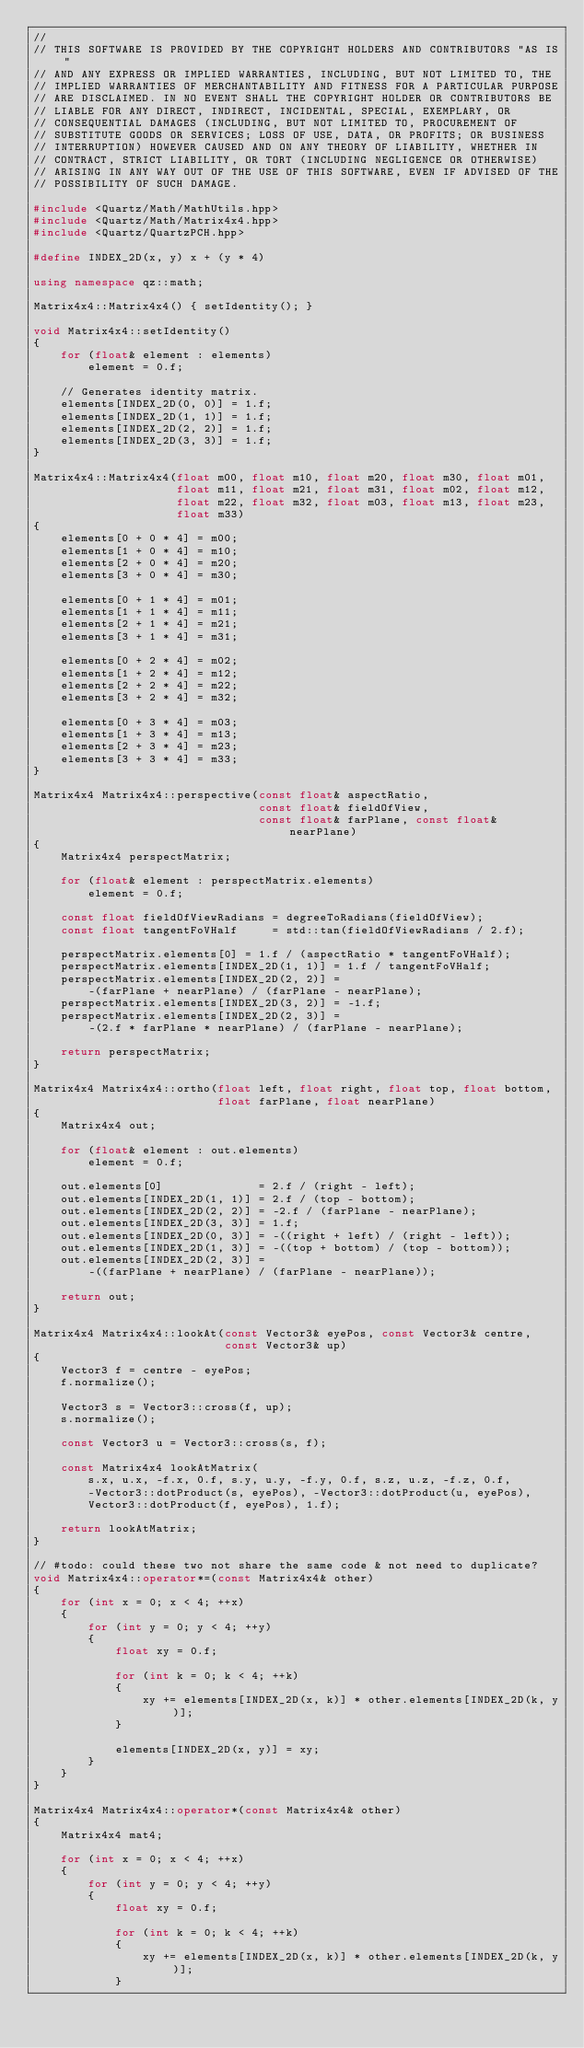<code> <loc_0><loc_0><loc_500><loc_500><_C++_>//
// THIS SOFTWARE IS PROVIDED BY THE COPYRIGHT HOLDERS AND CONTRIBUTORS "AS IS"
// AND ANY EXPRESS OR IMPLIED WARRANTIES, INCLUDING, BUT NOT LIMITED TO, THE
// IMPLIED WARRANTIES OF MERCHANTABILITY AND FITNESS FOR A PARTICULAR PURPOSE
// ARE DISCLAIMED. IN NO EVENT SHALL THE COPYRIGHT HOLDER OR CONTRIBUTORS BE
// LIABLE FOR ANY DIRECT, INDIRECT, INCIDENTAL, SPECIAL, EXEMPLARY, OR
// CONSEQUENTIAL DAMAGES (INCLUDING, BUT NOT LIMITED TO, PROCUREMENT OF
// SUBSTITUTE GOODS OR SERVICES; LOSS OF USE, DATA, OR PROFITS; OR BUSINESS
// INTERRUPTION) HOWEVER CAUSED AND ON ANY THEORY OF LIABILITY, WHETHER IN
// CONTRACT, STRICT LIABILITY, OR TORT (INCLUDING NEGLIGENCE OR OTHERWISE)
// ARISING IN ANY WAY OUT OF THE USE OF THIS SOFTWARE, EVEN IF ADVISED OF THE
// POSSIBILITY OF SUCH DAMAGE.

#include <Quartz/Math/MathUtils.hpp>
#include <Quartz/Math/Matrix4x4.hpp>
#include <Quartz/QuartzPCH.hpp>

#define INDEX_2D(x, y) x + (y * 4)

using namespace qz::math;

Matrix4x4::Matrix4x4() { setIdentity(); }

void Matrix4x4::setIdentity()
{
	for (float& element : elements)
		element = 0.f;

	// Generates identity matrix.
	elements[INDEX_2D(0, 0)] = 1.f;
	elements[INDEX_2D(1, 1)] = 1.f;
	elements[INDEX_2D(2, 2)] = 1.f;
	elements[INDEX_2D(3, 3)] = 1.f;
}

Matrix4x4::Matrix4x4(float m00, float m10, float m20, float m30, float m01,
                     float m11, float m21, float m31, float m02, float m12,
                     float m22, float m32, float m03, float m13, float m23,
                     float m33)
{
	elements[0 + 0 * 4] = m00;
	elements[1 + 0 * 4] = m10;
	elements[2 + 0 * 4] = m20;
	elements[3 + 0 * 4] = m30;

	elements[0 + 1 * 4] = m01;
	elements[1 + 1 * 4] = m11;
	elements[2 + 1 * 4] = m21;
	elements[3 + 1 * 4] = m31;

	elements[0 + 2 * 4] = m02;
	elements[1 + 2 * 4] = m12;
	elements[2 + 2 * 4] = m22;
	elements[3 + 2 * 4] = m32;

	elements[0 + 3 * 4] = m03;
	elements[1 + 3 * 4] = m13;
	elements[2 + 3 * 4] = m23;
	elements[3 + 3 * 4] = m33;
}

Matrix4x4 Matrix4x4::perspective(const float& aspectRatio,
                                 const float& fieldOfView,
                                 const float& farPlane, const float& nearPlane)
{
	Matrix4x4 perspectMatrix;

	for (float& element : perspectMatrix.elements)
		element = 0.f;

	const float fieldOfViewRadians = degreeToRadians(fieldOfView);
	const float tangentFoVHalf     = std::tan(fieldOfViewRadians / 2.f);

	perspectMatrix.elements[0] = 1.f / (aspectRatio * tangentFoVHalf);
	perspectMatrix.elements[INDEX_2D(1, 1)] = 1.f / tangentFoVHalf;
	perspectMatrix.elements[INDEX_2D(2, 2)] =
	    -(farPlane + nearPlane) / (farPlane - nearPlane);
	perspectMatrix.elements[INDEX_2D(3, 2)] = -1.f;
	perspectMatrix.elements[INDEX_2D(2, 3)] =
	    -(2.f * farPlane * nearPlane) / (farPlane - nearPlane);

	return perspectMatrix;
}

Matrix4x4 Matrix4x4::ortho(float left, float right, float top, float bottom,
                           float farPlane, float nearPlane)
{
	Matrix4x4 out;

	for (float& element : out.elements)
		element = 0.f;

	out.elements[0]              = 2.f / (right - left);
	out.elements[INDEX_2D(1, 1)] = 2.f / (top - bottom);
	out.elements[INDEX_2D(2, 2)] = -2.f / (farPlane - nearPlane);
	out.elements[INDEX_2D(3, 3)] = 1.f;
	out.elements[INDEX_2D(0, 3)] = -((right + left) / (right - left));
	out.elements[INDEX_2D(1, 3)] = -((top + bottom) / (top - bottom));
	out.elements[INDEX_2D(2, 3)] =
	    -((farPlane + nearPlane) / (farPlane - nearPlane));

	return out;
}

Matrix4x4 Matrix4x4::lookAt(const Vector3& eyePos, const Vector3& centre,
                            const Vector3& up)
{
	Vector3 f = centre - eyePos;
	f.normalize();

	Vector3 s = Vector3::cross(f, up);
	s.normalize();

	const Vector3 u = Vector3::cross(s, f);

	const Matrix4x4 lookAtMatrix(
	    s.x, u.x, -f.x, 0.f, s.y, u.y, -f.y, 0.f, s.z, u.z, -f.z, 0.f,
	    -Vector3::dotProduct(s, eyePos), -Vector3::dotProduct(u, eyePos),
	    Vector3::dotProduct(f, eyePos), 1.f);

	return lookAtMatrix;
}

// #todo: could these two not share the same code & not need to duplicate?
void Matrix4x4::operator*=(const Matrix4x4& other)
{
	for (int x = 0; x < 4; ++x)
	{
		for (int y = 0; y < 4; ++y)
		{
			float xy = 0.f;

			for (int k = 0; k < 4; ++k)
			{
				xy += elements[INDEX_2D(x, k)] * other.elements[INDEX_2D(k, y)];
			}

			elements[INDEX_2D(x, y)] = xy;
		}
	}
}

Matrix4x4 Matrix4x4::operator*(const Matrix4x4& other)
{
	Matrix4x4 mat4;

	for (int x = 0; x < 4; ++x)
	{
		for (int y = 0; y < 4; ++y)
		{
			float xy = 0.f;

			for (int k = 0; k < 4; ++k)
			{
				xy += elements[INDEX_2D(x, k)] * other.elements[INDEX_2D(k, y)];
			}
</code> 